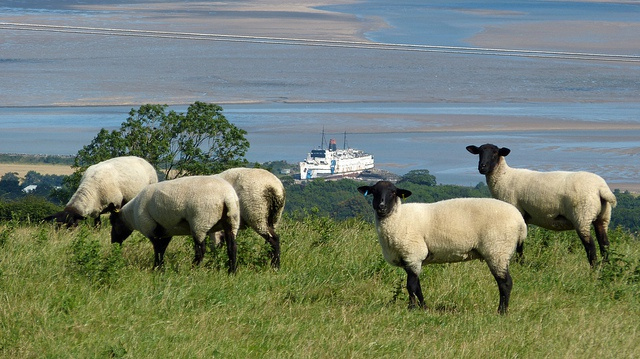Describe the objects in this image and their specific colors. I can see sheep in gray, tan, and black tones, sheep in gray, black, tan, and darkgreen tones, sheep in gray, black, and tan tones, sheep in gray, tan, beige, and black tones, and sheep in gray, black, tan, and darkgreen tones in this image. 